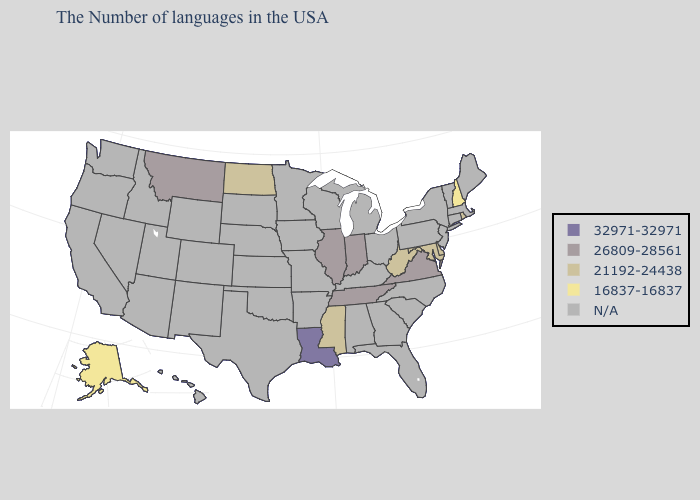What is the lowest value in the Northeast?
Be succinct. 16837-16837. Name the states that have a value in the range 32971-32971?
Short answer required. Louisiana. Is the legend a continuous bar?
Write a very short answer. No. Does New Hampshire have the highest value in the Northeast?
Be succinct. No. Name the states that have a value in the range 21192-24438?
Be succinct. Rhode Island, Delaware, Maryland, West Virginia, Mississippi, North Dakota. Name the states that have a value in the range 32971-32971?
Give a very brief answer. Louisiana. What is the value of Rhode Island?
Concise answer only. 21192-24438. Which states have the lowest value in the MidWest?
Keep it brief. North Dakota. Which states have the highest value in the USA?
Quick response, please. Louisiana. Which states have the lowest value in the South?
Concise answer only. Delaware, Maryland, West Virginia, Mississippi. What is the highest value in the West ?
Quick response, please. 26809-28561. Is the legend a continuous bar?
Give a very brief answer. No. Which states have the highest value in the USA?
Answer briefly. Louisiana. 